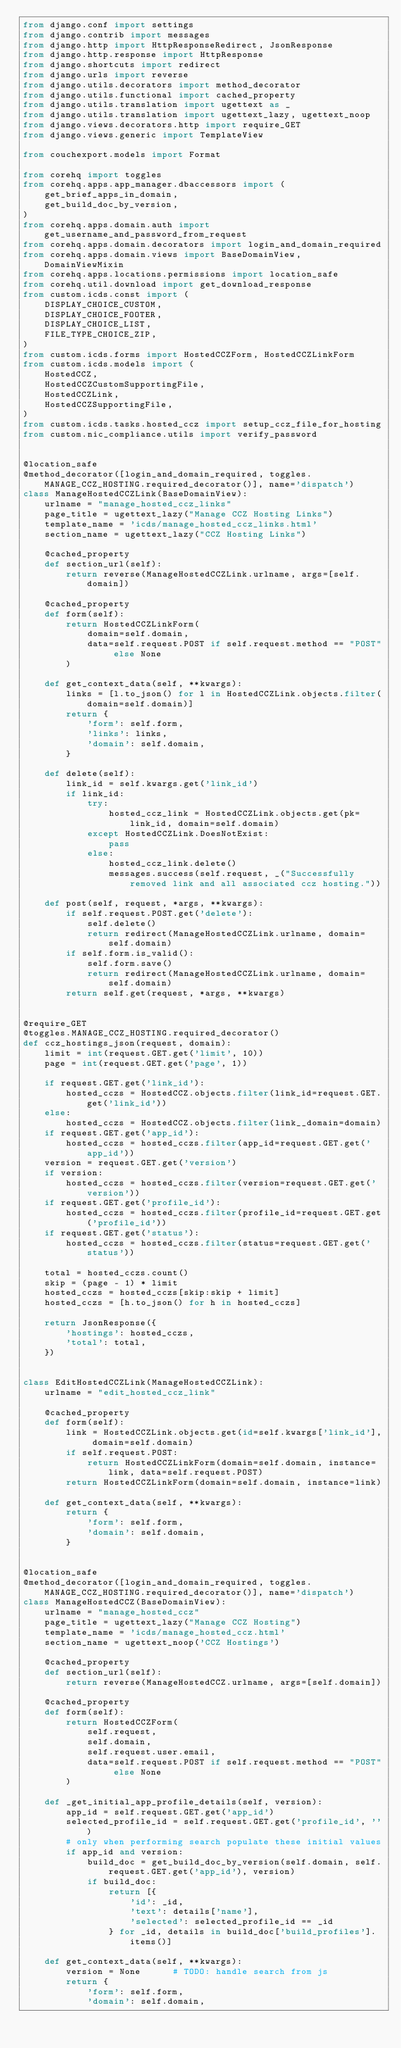<code> <loc_0><loc_0><loc_500><loc_500><_Python_>from django.conf import settings
from django.contrib import messages
from django.http import HttpResponseRedirect, JsonResponse
from django.http.response import HttpResponse
from django.shortcuts import redirect
from django.urls import reverse
from django.utils.decorators import method_decorator
from django.utils.functional import cached_property
from django.utils.translation import ugettext as _
from django.utils.translation import ugettext_lazy, ugettext_noop
from django.views.decorators.http import require_GET
from django.views.generic import TemplateView

from couchexport.models import Format

from corehq import toggles
from corehq.apps.app_manager.dbaccessors import (
    get_brief_apps_in_domain,
    get_build_doc_by_version,
)
from corehq.apps.domain.auth import get_username_and_password_from_request
from corehq.apps.domain.decorators import login_and_domain_required
from corehq.apps.domain.views import BaseDomainView, DomainViewMixin
from corehq.apps.locations.permissions import location_safe
from corehq.util.download import get_download_response
from custom.icds.const import (
    DISPLAY_CHOICE_CUSTOM,
    DISPLAY_CHOICE_FOOTER,
    DISPLAY_CHOICE_LIST,
    FILE_TYPE_CHOICE_ZIP,
)
from custom.icds.forms import HostedCCZForm, HostedCCZLinkForm
from custom.icds.models import (
    HostedCCZ,
    HostedCCZCustomSupportingFile,
    HostedCCZLink,
    HostedCCZSupportingFile,
)
from custom.icds.tasks.hosted_ccz import setup_ccz_file_for_hosting
from custom.nic_compliance.utils import verify_password


@location_safe
@method_decorator([login_and_domain_required, toggles.MANAGE_CCZ_HOSTING.required_decorator()], name='dispatch')
class ManageHostedCCZLink(BaseDomainView):
    urlname = "manage_hosted_ccz_links"
    page_title = ugettext_lazy("Manage CCZ Hosting Links")
    template_name = 'icds/manage_hosted_ccz_links.html'
    section_name = ugettext_lazy("CCZ Hosting Links")

    @cached_property
    def section_url(self):
        return reverse(ManageHostedCCZLink.urlname, args=[self.domain])

    @cached_property
    def form(self):
        return HostedCCZLinkForm(
            domain=self.domain,
            data=self.request.POST if self.request.method == "POST" else None
        )

    def get_context_data(self, **kwargs):
        links = [l.to_json() for l in HostedCCZLink.objects.filter(domain=self.domain)]
        return {
            'form': self.form,
            'links': links,
            'domain': self.domain,
        }

    def delete(self):
        link_id = self.kwargs.get('link_id')
        if link_id:
            try:
                hosted_ccz_link = HostedCCZLink.objects.get(pk=link_id, domain=self.domain)
            except HostedCCZLink.DoesNotExist:
                pass
            else:
                hosted_ccz_link.delete()
                messages.success(self.request, _("Successfully removed link and all associated ccz hosting."))

    def post(self, request, *args, **kwargs):
        if self.request.POST.get('delete'):
            self.delete()
            return redirect(ManageHostedCCZLink.urlname, domain=self.domain)
        if self.form.is_valid():
            self.form.save()
            return redirect(ManageHostedCCZLink.urlname, domain=self.domain)
        return self.get(request, *args, **kwargs)


@require_GET
@toggles.MANAGE_CCZ_HOSTING.required_decorator()
def ccz_hostings_json(request, domain):
    limit = int(request.GET.get('limit', 10))
    page = int(request.GET.get('page', 1))

    if request.GET.get('link_id'):
        hosted_cczs = HostedCCZ.objects.filter(link_id=request.GET.get('link_id'))
    else:
        hosted_cczs = HostedCCZ.objects.filter(link__domain=domain)
    if request.GET.get('app_id'):
        hosted_cczs = hosted_cczs.filter(app_id=request.GET.get('app_id'))
    version = request.GET.get('version')
    if version:
        hosted_cczs = hosted_cczs.filter(version=request.GET.get('version'))
    if request.GET.get('profile_id'):
        hosted_cczs = hosted_cczs.filter(profile_id=request.GET.get('profile_id'))
    if request.GET.get('status'):
        hosted_cczs = hosted_cczs.filter(status=request.GET.get('status'))

    total = hosted_cczs.count()
    skip = (page - 1) * limit
    hosted_cczs = hosted_cczs[skip:skip + limit]
    hosted_cczs = [h.to_json() for h in hosted_cczs]

    return JsonResponse({
        'hostings': hosted_cczs,
        'total': total,
    })


class EditHostedCCZLink(ManageHostedCCZLink):
    urlname = "edit_hosted_ccz_link"

    @cached_property
    def form(self):
        link = HostedCCZLink.objects.get(id=self.kwargs['link_id'], domain=self.domain)
        if self.request.POST:
            return HostedCCZLinkForm(domain=self.domain, instance=link, data=self.request.POST)
        return HostedCCZLinkForm(domain=self.domain, instance=link)

    def get_context_data(self, **kwargs):
        return {
            'form': self.form,
            'domain': self.domain,
        }


@location_safe
@method_decorator([login_and_domain_required, toggles.MANAGE_CCZ_HOSTING.required_decorator()], name='dispatch')
class ManageHostedCCZ(BaseDomainView):
    urlname = "manage_hosted_ccz"
    page_title = ugettext_lazy("Manage CCZ Hosting")
    template_name = 'icds/manage_hosted_ccz.html'
    section_name = ugettext_noop('CCZ Hostings')

    @cached_property
    def section_url(self):
        return reverse(ManageHostedCCZ.urlname, args=[self.domain])

    @cached_property
    def form(self):
        return HostedCCZForm(
            self.request,
            self.domain,
            self.request.user.email,
            data=self.request.POST if self.request.method == "POST" else None
        )

    def _get_initial_app_profile_details(self, version):
        app_id = self.request.GET.get('app_id')
        selected_profile_id = self.request.GET.get('profile_id', '')
        # only when performing search populate these initial values
        if app_id and version:
            build_doc = get_build_doc_by_version(self.domain, self.request.GET.get('app_id'), version)
            if build_doc:
                return [{
                    'id': _id,
                    'text': details['name'],
                    'selected': selected_profile_id == _id
                } for _id, details in build_doc['build_profiles'].items()]

    def get_context_data(self, **kwargs):
        version = None      # TODO: handle search from js
        return {
            'form': self.form,
            'domain': self.domain,</code> 